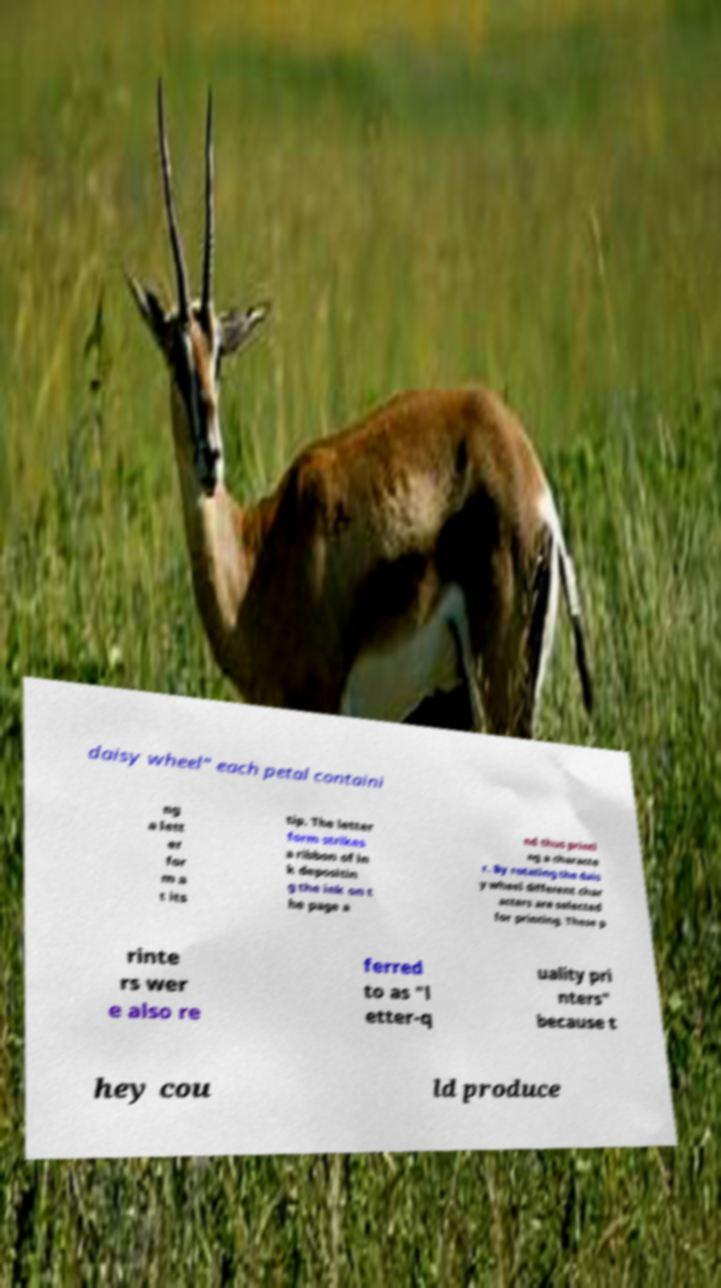Please read and relay the text visible in this image. What does it say? daisy wheel" each petal containi ng a lett er for m a t its tip. The letter form strikes a ribbon of in k depositin g the ink on t he page a nd thus printi ng a characte r. By rotating the dais y wheel different char acters are selected for printing. These p rinte rs wer e also re ferred to as "l etter-q uality pri nters" because t hey cou ld produce 